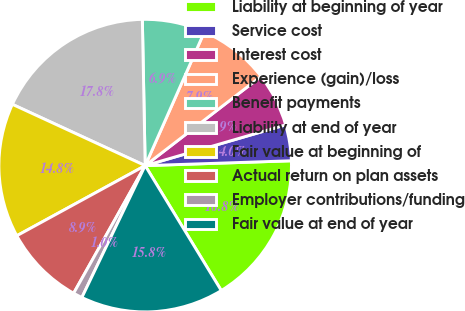Convert chart to OTSL. <chart><loc_0><loc_0><loc_500><loc_500><pie_chart><fcel>Liability at beginning of year<fcel>Service cost<fcel>Interest cost<fcel>Experience (gain)/loss<fcel>Benefit payments<fcel>Liability at end of year<fcel>Fair value at beginning of<fcel>Actual return on plan assets<fcel>Employer contributions/funding<fcel>Fair value at end of year<nl><fcel>16.82%<fcel>3.97%<fcel>5.95%<fcel>7.92%<fcel>6.94%<fcel>17.81%<fcel>14.84%<fcel>8.91%<fcel>1.01%<fcel>15.83%<nl></chart> 